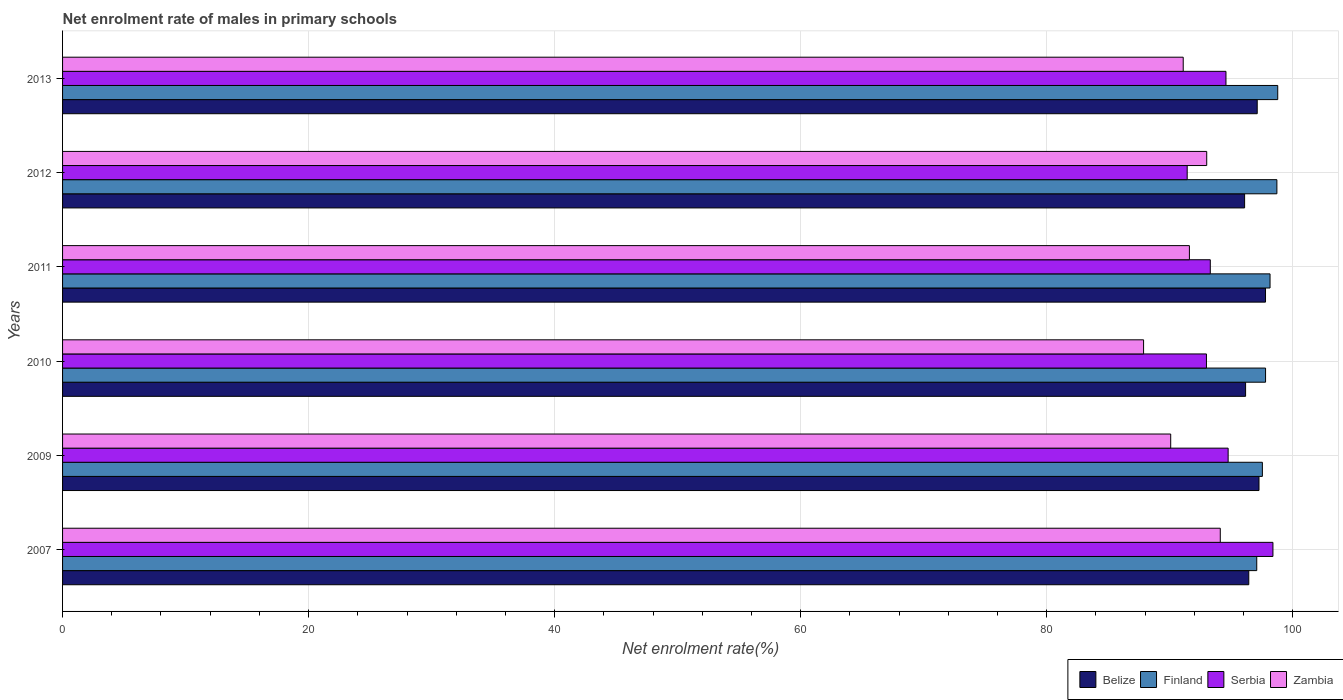How many groups of bars are there?
Your response must be concise. 6. What is the label of the 5th group of bars from the top?
Provide a short and direct response. 2009. What is the net enrolment rate of males in primary schools in Serbia in 2012?
Give a very brief answer. 91.43. Across all years, what is the maximum net enrolment rate of males in primary schools in Zambia?
Provide a succinct answer. 94.12. Across all years, what is the minimum net enrolment rate of males in primary schools in Zambia?
Your answer should be compact. 87.88. What is the total net enrolment rate of males in primary schools in Belize in the graph?
Give a very brief answer. 580.88. What is the difference between the net enrolment rate of males in primary schools in Serbia in 2007 and that in 2009?
Offer a terse response. 3.64. What is the difference between the net enrolment rate of males in primary schools in Belize in 2010 and the net enrolment rate of males in primary schools in Finland in 2011?
Your response must be concise. -1.99. What is the average net enrolment rate of males in primary schools in Belize per year?
Your response must be concise. 96.81. In the year 2011, what is the difference between the net enrolment rate of males in primary schools in Zambia and net enrolment rate of males in primary schools in Serbia?
Offer a terse response. -1.7. In how many years, is the net enrolment rate of males in primary schools in Serbia greater than 16 %?
Ensure brevity in your answer.  6. What is the ratio of the net enrolment rate of males in primary schools in Serbia in 2011 to that in 2013?
Ensure brevity in your answer.  0.99. Is the difference between the net enrolment rate of males in primary schools in Zambia in 2011 and 2012 greater than the difference between the net enrolment rate of males in primary schools in Serbia in 2011 and 2012?
Offer a very short reply. No. What is the difference between the highest and the second highest net enrolment rate of males in primary schools in Zambia?
Make the answer very short. 1.1. What is the difference between the highest and the lowest net enrolment rate of males in primary schools in Zambia?
Provide a succinct answer. 6.23. Is it the case that in every year, the sum of the net enrolment rate of males in primary schools in Finland and net enrolment rate of males in primary schools in Zambia is greater than the sum of net enrolment rate of males in primary schools in Belize and net enrolment rate of males in primary schools in Serbia?
Your answer should be very brief. Yes. What does the 1st bar from the top in 2013 represents?
Keep it short and to the point. Zambia. What does the 4th bar from the bottom in 2009 represents?
Provide a succinct answer. Zambia. Are all the bars in the graph horizontal?
Offer a terse response. Yes. How many years are there in the graph?
Your response must be concise. 6. What is the difference between two consecutive major ticks on the X-axis?
Provide a succinct answer. 20. Are the values on the major ticks of X-axis written in scientific E-notation?
Provide a succinct answer. No. Does the graph contain any zero values?
Your response must be concise. No. Does the graph contain grids?
Provide a short and direct response. Yes. How many legend labels are there?
Provide a short and direct response. 4. What is the title of the graph?
Your response must be concise. Net enrolment rate of males in primary schools. Does "United Kingdom" appear as one of the legend labels in the graph?
Your response must be concise. No. What is the label or title of the X-axis?
Provide a short and direct response. Net enrolment rate(%). What is the Net enrolment rate(%) in Belize in 2007?
Ensure brevity in your answer.  96.43. What is the Net enrolment rate(%) of Finland in 2007?
Your response must be concise. 97.08. What is the Net enrolment rate(%) in Serbia in 2007?
Provide a succinct answer. 98.4. What is the Net enrolment rate(%) of Zambia in 2007?
Offer a terse response. 94.12. What is the Net enrolment rate(%) of Belize in 2009?
Your response must be concise. 97.26. What is the Net enrolment rate(%) in Finland in 2009?
Offer a very short reply. 97.54. What is the Net enrolment rate(%) in Serbia in 2009?
Offer a terse response. 94.75. What is the Net enrolment rate(%) of Zambia in 2009?
Make the answer very short. 90.09. What is the Net enrolment rate(%) in Belize in 2010?
Your answer should be very brief. 96.17. What is the Net enrolment rate(%) in Finland in 2010?
Your response must be concise. 97.8. What is the Net enrolment rate(%) of Serbia in 2010?
Make the answer very short. 92.99. What is the Net enrolment rate(%) in Zambia in 2010?
Ensure brevity in your answer.  87.88. What is the Net enrolment rate(%) in Belize in 2011?
Your answer should be very brief. 97.79. What is the Net enrolment rate(%) of Finland in 2011?
Make the answer very short. 98.16. What is the Net enrolment rate(%) in Serbia in 2011?
Give a very brief answer. 93.3. What is the Net enrolment rate(%) in Zambia in 2011?
Keep it short and to the point. 91.61. What is the Net enrolment rate(%) in Belize in 2012?
Give a very brief answer. 96.09. What is the Net enrolment rate(%) of Finland in 2012?
Provide a succinct answer. 98.72. What is the Net enrolment rate(%) of Serbia in 2012?
Your answer should be compact. 91.43. What is the Net enrolment rate(%) in Zambia in 2012?
Ensure brevity in your answer.  93.01. What is the Net enrolment rate(%) in Belize in 2013?
Your answer should be compact. 97.12. What is the Net enrolment rate(%) in Finland in 2013?
Offer a very short reply. 98.79. What is the Net enrolment rate(%) of Serbia in 2013?
Your response must be concise. 94.58. What is the Net enrolment rate(%) of Zambia in 2013?
Provide a succinct answer. 91.1. Across all years, what is the maximum Net enrolment rate(%) of Belize?
Provide a succinct answer. 97.79. Across all years, what is the maximum Net enrolment rate(%) of Finland?
Your response must be concise. 98.79. Across all years, what is the maximum Net enrolment rate(%) of Serbia?
Offer a terse response. 98.4. Across all years, what is the maximum Net enrolment rate(%) of Zambia?
Your answer should be compact. 94.12. Across all years, what is the minimum Net enrolment rate(%) of Belize?
Your answer should be very brief. 96.09. Across all years, what is the minimum Net enrolment rate(%) of Finland?
Offer a very short reply. 97.08. Across all years, what is the minimum Net enrolment rate(%) in Serbia?
Your answer should be very brief. 91.43. Across all years, what is the minimum Net enrolment rate(%) of Zambia?
Your answer should be compact. 87.88. What is the total Net enrolment rate(%) of Belize in the graph?
Your answer should be compact. 580.88. What is the total Net enrolment rate(%) in Finland in the graph?
Provide a succinct answer. 588.08. What is the total Net enrolment rate(%) in Serbia in the graph?
Make the answer very short. 565.45. What is the total Net enrolment rate(%) in Zambia in the graph?
Offer a very short reply. 547.8. What is the difference between the Net enrolment rate(%) in Belize in 2007 and that in 2009?
Make the answer very short. -0.83. What is the difference between the Net enrolment rate(%) in Finland in 2007 and that in 2009?
Your response must be concise. -0.46. What is the difference between the Net enrolment rate(%) of Serbia in 2007 and that in 2009?
Your response must be concise. 3.64. What is the difference between the Net enrolment rate(%) in Zambia in 2007 and that in 2009?
Keep it short and to the point. 4.03. What is the difference between the Net enrolment rate(%) in Belize in 2007 and that in 2010?
Keep it short and to the point. 0.26. What is the difference between the Net enrolment rate(%) of Finland in 2007 and that in 2010?
Keep it short and to the point. -0.72. What is the difference between the Net enrolment rate(%) of Serbia in 2007 and that in 2010?
Give a very brief answer. 5.41. What is the difference between the Net enrolment rate(%) of Zambia in 2007 and that in 2010?
Your answer should be very brief. 6.23. What is the difference between the Net enrolment rate(%) of Belize in 2007 and that in 2011?
Provide a succinct answer. -1.36. What is the difference between the Net enrolment rate(%) in Finland in 2007 and that in 2011?
Offer a very short reply. -1.08. What is the difference between the Net enrolment rate(%) of Serbia in 2007 and that in 2011?
Ensure brevity in your answer.  5.09. What is the difference between the Net enrolment rate(%) of Zambia in 2007 and that in 2011?
Your answer should be very brief. 2.51. What is the difference between the Net enrolment rate(%) in Belize in 2007 and that in 2012?
Your answer should be compact. 0.34. What is the difference between the Net enrolment rate(%) in Finland in 2007 and that in 2012?
Keep it short and to the point. -1.64. What is the difference between the Net enrolment rate(%) of Serbia in 2007 and that in 2012?
Make the answer very short. 6.97. What is the difference between the Net enrolment rate(%) in Zambia in 2007 and that in 2012?
Make the answer very short. 1.1. What is the difference between the Net enrolment rate(%) in Belize in 2007 and that in 2013?
Offer a very short reply. -0.69. What is the difference between the Net enrolment rate(%) of Finland in 2007 and that in 2013?
Your answer should be very brief. -1.71. What is the difference between the Net enrolment rate(%) in Serbia in 2007 and that in 2013?
Your answer should be compact. 3.82. What is the difference between the Net enrolment rate(%) in Zambia in 2007 and that in 2013?
Give a very brief answer. 3.01. What is the difference between the Net enrolment rate(%) of Belize in 2009 and that in 2010?
Provide a succinct answer. 1.09. What is the difference between the Net enrolment rate(%) in Finland in 2009 and that in 2010?
Provide a succinct answer. -0.26. What is the difference between the Net enrolment rate(%) in Serbia in 2009 and that in 2010?
Provide a short and direct response. 1.76. What is the difference between the Net enrolment rate(%) in Zambia in 2009 and that in 2010?
Your answer should be very brief. 2.2. What is the difference between the Net enrolment rate(%) of Belize in 2009 and that in 2011?
Ensure brevity in your answer.  -0.53. What is the difference between the Net enrolment rate(%) of Finland in 2009 and that in 2011?
Your answer should be very brief. -0.62. What is the difference between the Net enrolment rate(%) in Serbia in 2009 and that in 2011?
Your answer should be very brief. 1.45. What is the difference between the Net enrolment rate(%) in Zambia in 2009 and that in 2011?
Your response must be concise. -1.52. What is the difference between the Net enrolment rate(%) of Belize in 2009 and that in 2012?
Your answer should be very brief. 1.17. What is the difference between the Net enrolment rate(%) of Finland in 2009 and that in 2012?
Offer a terse response. -1.18. What is the difference between the Net enrolment rate(%) of Serbia in 2009 and that in 2012?
Your answer should be very brief. 3.33. What is the difference between the Net enrolment rate(%) of Zambia in 2009 and that in 2012?
Give a very brief answer. -2.93. What is the difference between the Net enrolment rate(%) of Belize in 2009 and that in 2013?
Offer a terse response. 0.15. What is the difference between the Net enrolment rate(%) of Finland in 2009 and that in 2013?
Provide a succinct answer. -1.25. What is the difference between the Net enrolment rate(%) in Serbia in 2009 and that in 2013?
Ensure brevity in your answer.  0.18. What is the difference between the Net enrolment rate(%) in Zambia in 2009 and that in 2013?
Your answer should be very brief. -1.02. What is the difference between the Net enrolment rate(%) of Belize in 2010 and that in 2011?
Provide a succinct answer. -1.62. What is the difference between the Net enrolment rate(%) in Finland in 2010 and that in 2011?
Give a very brief answer. -0.36. What is the difference between the Net enrolment rate(%) in Serbia in 2010 and that in 2011?
Offer a terse response. -0.31. What is the difference between the Net enrolment rate(%) of Zambia in 2010 and that in 2011?
Your answer should be very brief. -3.73. What is the difference between the Net enrolment rate(%) in Belize in 2010 and that in 2012?
Offer a terse response. 0.08. What is the difference between the Net enrolment rate(%) in Finland in 2010 and that in 2012?
Give a very brief answer. -0.92. What is the difference between the Net enrolment rate(%) of Serbia in 2010 and that in 2012?
Your answer should be compact. 1.57. What is the difference between the Net enrolment rate(%) in Zambia in 2010 and that in 2012?
Your answer should be very brief. -5.13. What is the difference between the Net enrolment rate(%) in Belize in 2010 and that in 2013?
Keep it short and to the point. -0.94. What is the difference between the Net enrolment rate(%) in Finland in 2010 and that in 2013?
Offer a terse response. -0.99. What is the difference between the Net enrolment rate(%) in Serbia in 2010 and that in 2013?
Offer a very short reply. -1.59. What is the difference between the Net enrolment rate(%) of Zambia in 2010 and that in 2013?
Offer a terse response. -3.22. What is the difference between the Net enrolment rate(%) in Belize in 2011 and that in 2012?
Your answer should be compact. 1.7. What is the difference between the Net enrolment rate(%) in Finland in 2011 and that in 2012?
Give a very brief answer. -0.56. What is the difference between the Net enrolment rate(%) of Serbia in 2011 and that in 2012?
Your answer should be very brief. 1.88. What is the difference between the Net enrolment rate(%) of Zambia in 2011 and that in 2012?
Your response must be concise. -1.41. What is the difference between the Net enrolment rate(%) of Belize in 2011 and that in 2013?
Provide a succinct answer. 0.67. What is the difference between the Net enrolment rate(%) of Finland in 2011 and that in 2013?
Your answer should be very brief. -0.62. What is the difference between the Net enrolment rate(%) in Serbia in 2011 and that in 2013?
Keep it short and to the point. -1.27. What is the difference between the Net enrolment rate(%) of Zambia in 2011 and that in 2013?
Give a very brief answer. 0.5. What is the difference between the Net enrolment rate(%) of Belize in 2012 and that in 2013?
Make the answer very short. -1.03. What is the difference between the Net enrolment rate(%) in Finland in 2012 and that in 2013?
Provide a succinct answer. -0.07. What is the difference between the Net enrolment rate(%) in Serbia in 2012 and that in 2013?
Offer a terse response. -3.15. What is the difference between the Net enrolment rate(%) of Zambia in 2012 and that in 2013?
Your response must be concise. 1.91. What is the difference between the Net enrolment rate(%) in Belize in 2007 and the Net enrolment rate(%) in Finland in 2009?
Your answer should be compact. -1.11. What is the difference between the Net enrolment rate(%) in Belize in 2007 and the Net enrolment rate(%) in Serbia in 2009?
Keep it short and to the point. 1.68. What is the difference between the Net enrolment rate(%) in Belize in 2007 and the Net enrolment rate(%) in Zambia in 2009?
Provide a short and direct response. 6.35. What is the difference between the Net enrolment rate(%) of Finland in 2007 and the Net enrolment rate(%) of Serbia in 2009?
Your response must be concise. 2.33. What is the difference between the Net enrolment rate(%) in Finland in 2007 and the Net enrolment rate(%) in Zambia in 2009?
Your response must be concise. 7. What is the difference between the Net enrolment rate(%) in Serbia in 2007 and the Net enrolment rate(%) in Zambia in 2009?
Provide a succinct answer. 8.31. What is the difference between the Net enrolment rate(%) in Belize in 2007 and the Net enrolment rate(%) in Finland in 2010?
Give a very brief answer. -1.36. What is the difference between the Net enrolment rate(%) in Belize in 2007 and the Net enrolment rate(%) in Serbia in 2010?
Keep it short and to the point. 3.44. What is the difference between the Net enrolment rate(%) in Belize in 2007 and the Net enrolment rate(%) in Zambia in 2010?
Make the answer very short. 8.55. What is the difference between the Net enrolment rate(%) of Finland in 2007 and the Net enrolment rate(%) of Serbia in 2010?
Provide a succinct answer. 4.09. What is the difference between the Net enrolment rate(%) of Finland in 2007 and the Net enrolment rate(%) of Zambia in 2010?
Your response must be concise. 9.2. What is the difference between the Net enrolment rate(%) of Serbia in 2007 and the Net enrolment rate(%) of Zambia in 2010?
Your answer should be compact. 10.52. What is the difference between the Net enrolment rate(%) of Belize in 2007 and the Net enrolment rate(%) of Finland in 2011?
Your answer should be very brief. -1.73. What is the difference between the Net enrolment rate(%) in Belize in 2007 and the Net enrolment rate(%) in Serbia in 2011?
Give a very brief answer. 3.13. What is the difference between the Net enrolment rate(%) of Belize in 2007 and the Net enrolment rate(%) of Zambia in 2011?
Provide a short and direct response. 4.83. What is the difference between the Net enrolment rate(%) in Finland in 2007 and the Net enrolment rate(%) in Serbia in 2011?
Provide a succinct answer. 3.78. What is the difference between the Net enrolment rate(%) in Finland in 2007 and the Net enrolment rate(%) in Zambia in 2011?
Offer a very short reply. 5.47. What is the difference between the Net enrolment rate(%) of Serbia in 2007 and the Net enrolment rate(%) of Zambia in 2011?
Make the answer very short. 6.79. What is the difference between the Net enrolment rate(%) of Belize in 2007 and the Net enrolment rate(%) of Finland in 2012?
Provide a succinct answer. -2.29. What is the difference between the Net enrolment rate(%) of Belize in 2007 and the Net enrolment rate(%) of Serbia in 2012?
Make the answer very short. 5.01. What is the difference between the Net enrolment rate(%) of Belize in 2007 and the Net enrolment rate(%) of Zambia in 2012?
Provide a short and direct response. 3.42. What is the difference between the Net enrolment rate(%) in Finland in 2007 and the Net enrolment rate(%) in Serbia in 2012?
Your response must be concise. 5.66. What is the difference between the Net enrolment rate(%) in Finland in 2007 and the Net enrolment rate(%) in Zambia in 2012?
Your answer should be very brief. 4.07. What is the difference between the Net enrolment rate(%) in Serbia in 2007 and the Net enrolment rate(%) in Zambia in 2012?
Give a very brief answer. 5.38. What is the difference between the Net enrolment rate(%) in Belize in 2007 and the Net enrolment rate(%) in Finland in 2013?
Your answer should be very brief. -2.35. What is the difference between the Net enrolment rate(%) of Belize in 2007 and the Net enrolment rate(%) of Serbia in 2013?
Make the answer very short. 1.85. What is the difference between the Net enrolment rate(%) of Belize in 2007 and the Net enrolment rate(%) of Zambia in 2013?
Offer a very short reply. 5.33. What is the difference between the Net enrolment rate(%) in Finland in 2007 and the Net enrolment rate(%) in Serbia in 2013?
Provide a short and direct response. 2.5. What is the difference between the Net enrolment rate(%) of Finland in 2007 and the Net enrolment rate(%) of Zambia in 2013?
Your answer should be very brief. 5.98. What is the difference between the Net enrolment rate(%) in Serbia in 2007 and the Net enrolment rate(%) in Zambia in 2013?
Your answer should be compact. 7.29. What is the difference between the Net enrolment rate(%) in Belize in 2009 and the Net enrolment rate(%) in Finland in 2010?
Provide a short and direct response. -0.53. What is the difference between the Net enrolment rate(%) of Belize in 2009 and the Net enrolment rate(%) of Serbia in 2010?
Keep it short and to the point. 4.27. What is the difference between the Net enrolment rate(%) in Belize in 2009 and the Net enrolment rate(%) in Zambia in 2010?
Your answer should be very brief. 9.38. What is the difference between the Net enrolment rate(%) of Finland in 2009 and the Net enrolment rate(%) of Serbia in 2010?
Make the answer very short. 4.55. What is the difference between the Net enrolment rate(%) of Finland in 2009 and the Net enrolment rate(%) of Zambia in 2010?
Offer a terse response. 9.66. What is the difference between the Net enrolment rate(%) of Serbia in 2009 and the Net enrolment rate(%) of Zambia in 2010?
Offer a very short reply. 6.87. What is the difference between the Net enrolment rate(%) in Belize in 2009 and the Net enrolment rate(%) in Finland in 2011?
Your answer should be very brief. -0.9. What is the difference between the Net enrolment rate(%) in Belize in 2009 and the Net enrolment rate(%) in Serbia in 2011?
Offer a very short reply. 3.96. What is the difference between the Net enrolment rate(%) in Belize in 2009 and the Net enrolment rate(%) in Zambia in 2011?
Your answer should be compact. 5.66. What is the difference between the Net enrolment rate(%) in Finland in 2009 and the Net enrolment rate(%) in Serbia in 2011?
Provide a short and direct response. 4.23. What is the difference between the Net enrolment rate(%) of Finland in 2009 and the Net enrolment rate(%) of Zambia in 2011?
Your answer should be compact. 5.93. What is the difference between the Net enrolment rate(%) of Serbia in 2009 and the Net enrolment rate(%) of Zambia in 2011?
Provide a short and direct response. 3.15. What is the difference between the Net enrolment rate(%) of Belize in 2009 and the Net enrolment rate(%) of Finland in 2012?
Keep it short and to the point. -1.45. What is the difference between the Net enrolment rate(%) in Belize in 2009 and the Net enrolment rate(%) in Serbia in 2012?
Your answer should be compact. 5.84. What is the difference between the Net enrolment rate(%) of Belize in 2009 and the Net enrolment rate(%) of Zambia in 2012?
Provide a succinct answer. 4.25. What is the difference between the Net enrolment rate(%) of Finland in 2009 and the Net enrolment rate(%) of Serbia in 2012?
Make the answer very short. 6.11. What is the difference between the Net enrolment rate(%) in Finland in 2009 and the Net enrolment rate(%) in Zambia in 2012?
Your answer should be compact. 4.53. What is the difference between the Net enrolment rate(%) of Serbia in 2009 and the Net enrolment rate(%) of Zambia in 2012?
Keep it short and to the point. 1.74. What is the difference between the Net enrolment rate(%) of Belize in 2009 and the Net enrolment rate(%) of Finland in 2013?
Your response must be concise. -1.52. What is the difference between the Net enrolment rate(%) in Belize in 2009 and the Net enrolment rate(%) in Serbia in 2013?
Your response must be concise. 2.69. What is the difference between the Net enrolment rate(%) of Belize in 2009 and the Net enrolment rate(%) of Zambia in 2013?
Your response must be concise. 6.16. What is the difference between the Net enrolment rate(%) of Finland in 2009 and the Net enrolment rate(%) of Serbia in 2013?
Ensure brevity in your answer.  2.96. What is the difference between the Net enrolment rate(%) of Finland in 2009 and the Net enrolment rate(%) of Zambia in 2013?
Offer a very short reply. 6.44. What is the difference between the Net enrolment rate(%) of Serbia in 2009 and the Net enrolment rate(%) of Zambia in 2013?
Provide a short and direct response. 3.65. What is the difference between the Net enrolment rate(%) in Belize in 2010 and the Net enrolment rate(%) in Finland in 2011?
Your response must be concise. -1.99. What is the difference between the Net enrolment rate(%) of Belize in 2010 and the Net enrolment rate(%) of Serbia in 2011?
Your answer should be very brief. 2.87. What is the difference between the Net enrolment rate(%) of Belize in 2010 and the Net enrolment rate(%) of Zambia in 2011?
Your response must be concise. 4.57. What is the difference between the Net enrolment rate(%) of Finland in 2010 and the Net enrolment rate(%) of Serbia in 2011?
Your response must be concise. 4.49. What is the difference between the Net enrolment rate(%) in Finland in 2010 and the Net enrolment rate(%) in Zambia in 2011?
Offer a terse response. 6.19. What is the difference between the Net enrolment rate(%) in Serbia in 2010 and the Net enrolment rate(%) in Zambia in 2011?
Your answer should be compact. 1.39. What is the difference between the Net enrolment rate(%) in Belize in 2010 and the Net enrolment rate(%) in Finland in 2012?
Provide a succinct answer. -2.54. What is the difference between the Net enrolment rate(%) in Belize in 2010 and the Net enrolment rate(%) in Serbia in 2012?
Keep it short and to the point. 4.75. What is the difference between the Net enrolment rate(%) in Belize in 2010 and the Net enrolment rate(%) in Zambia in 2012?
Your answer should be compact. 3.16. What is the difference between the Net enrolment rate(%) of Finland in 2010 and the Net enrolment rate(%) of Serbia in 2012?
Offer a terse response. 6.37. What is the difference between the Net enrolment rate(%) of Finland in 2010 and the Net enrolment rate(%) of Zambia in 2012?
Provide a succinct answer. 4.78. What is the difference between the Net enrolment rate(%) in Serbia in 2010 and the Net enrolment rate(%) in Zambia in 2012?
Give a very brief answer. -0.02. What is the difference between the Net enrolment rate(%) in Belize in 2010 and the Net enrolment rate(%) in Finland in 2013?
Offer a very short reply. -2.61. What is the difference between the Net enrolment rate(%) of Belize in 2010 and the Net enrolment rate(%) of Serbia in 2013?
Provide a succinct answer. 1.6. What is the difference between the Net enrolment rate(%) in Belize in 2010 and the Net enrolment rate(%) in Zambia in 2013?
Your answer should be compact. 5.07. What is the difference between the Net enrolment rate(%) of Finland in 2010 and the Net enrolment rate(%) of Serbia in 2013?
Provide a short and direct response. 3.22. What is the difference between the Net enrolment rate(%) in Finland in 2010 and the Net enrolment rate(%) in Zambia in 2013?
Offer a terse response. 6.69. What is the difference between the Net enrolment rate(%) of Serbia in 2010 and the Net enrolment rate(%) of Zambia in 2013?
Give a very brief answer. 1.89. What is the difference between the Net enrolment rate(%) in Belize in 2011 and the Net enrolment rate(%) in Finland in 2012?
Provide a short and direct response. -0.92. What is the difference between the Net enrolment rate(%) in Belize in 2011 and the Net enrolment rate(%) in Serbia in 2012?
Your response must be concise. 6.37. What is the difference between the Net enrolment rate(%) of Belize in 2011 and the Net enrolment rate(%) of Zambia in 2012?
Your answer should be compact. 4.78. What is the difference between the Net enrolment rate(%) of Finland in 2011 and the Net enrolment rate(%) of Serbia in 2012?
Provide a short and direct response. 6.74. What is the difference between the Net enrolment rate(%) in Finland in 2011 and the Net enrolment rate(%) in Zambia in 2012?
Provide a short and direct response. 5.15. What is the difference between the Net enrolment rate(%) in Serbia in 2011 and the Net enrolment rate(%) in Zambia in 2012?
Ensure brevity in your answer.  0.29. What is the difference between the Net enrolment rate(%) in Belize in 2011 and the Net enrolment rate(%) in Finland in 2013?
Ensure brevity in your answer.  -0.99. What is the difference between the Net enrolment rate(%) of Belize in 2011 and the Net enrolment rate(%) of Serbia in 2013?
Offer a very short reply. 3.21. What is the difference between the Net enrolment rate(%) in Belize in 2011 and the Net enrolment rate(%) in Zambia in 2013?
Keep it short and to the point. 6.69. What is the difference between the Net enrolment rate(%) in Finland in 2011 and the Net enrolment rate(%) in Serbia in 2013?
Provide a succinct answer. 3.58. What is the difference between the Net enrolment rate(%) of Finland in 2011 and the Net enrolment rate(%) of Zambia in 2013?
Give a very brief answer. 7.06. What is the difference between the Net enrolment rate(%) in Serbia in 2011 and the Net enrolment rate(%) in Zambia in 2013?
Ensure brevity in your answer.  2.2. What is the difference between the Net enrolment rate(%) in Belize in 2012 and the Net enrolment rate(%) in Finland in 2013?
Offer a very short reply. -2.69. What is the difference between the Net enrolment rate(%) of Belize in 2012 and the Net enrolment rate(%) of Serbia in 2013?
Keep it short and to the point. 1.51. What is the difference between the Net enrolment rate(%) of Belize in 2012 and the Net enrolment rate(%) of Zambia in 2013?
Ensure brevity in your answer.  4.99. What is the difference between the Net enrolment rate(%) in Finland in 2012 and the Net enrolment rate(%) in Serbia in 2013?
Give a very brief answer. 4.14. What is the difference between the Net enrolment rate(%) of Finland in 2012 and the Net enrolment rate(%) of Zambia in 2013?
Your answer should be very brief. 7.62. What is the difference between the Net enrolment rate(%) in Serbia in 2012 and the Net enrolment rate(%) in Zambia in 2013?
Offer a terse response. 0.32. What is the average Net enrolment rate(%) in Belize per year?
Provide a short and direct response. 96.81. What is the average Net enrolment rate(%) in Finland per year?
Offer a very short reply. 98.01. What is the average Net enrolment rate(%) in Serbia per year?
Make the answer very short. 94.24. What is the average Net enrolment rate(%) in Zambia per year?
Give a very brief answer. 91.3. In the year 2007, what is the difference between the Net enrolment rate(%) of Belize and Net enrolment rate(%) of Finland?
Offer a very short reply. -0.65. In the year 2007, what is the difference between the Net enrolment rate(%) in Belize and Net enrolment rate(%) in Serbia?
Offer a terse response. -1.96. In the year 2007, what is the difference between the Net enrolment rate(%) in Belize and Net enrolment rate(%) in Zambia?
Give a very brief answer. 2.32. In the year 2007, what is the difference between the Net enrolment rate(%) in Finland and Net enrolment rate(%) in Serbia?
Keep it short and to the point. -1.32. In the year 2007, what is the difference between the Net enrolment rate(%) of Finland and Net enrolment rate(%) of Zambia?
Ensure brevity in your answer.  2.97. In the year 2007, what is the difference between the Net enrolment rate(%) of Serbia and Net enrolment rate(%) of Zambia?
Offer a very short reply. 4.28. In the year 2009, what is the difference between the Net enrolment rate(%) in Belize and Net enrolment rate(%) in Finland?
Give a very brief answer. -0.27. In the year 2009, what is the difference between the Net enrolment rate(%) in Belize and Net enrolment rate(%) in Serbia?
Provide a succinct answer. 2.51. In the year 2009, what is the difference between the Net enrolment rate(%) in Belize and Net enrolment rate(%) in Zambia?
Your response must be concise. 7.18. In the year 2009, what is the difference between the Net enrolment rate(%) in Finland and Net enrolment rate(%) in Serbia?
Your answer should be very brief. 2.78. In the year 2009, what is the difference between the Net enrolment rate(%) of Finland and Net enrolment rate(%) of Zambia?
Keep it short and to the point. 7.45. In the year 2009, what is the difference between the Net enrolment rate(%) in Serbia and Net enrolment rate(%) in Zambia?
Provide a short and direct response. 4.67. In the year 2010, what is the difference between the Net enrolment rate(%) of Belize and Net enrolment rate(%) of Finland?
Your answer should be very brief. -1.62. In the year 2010, what is the difference between the Net enrolment rate(%) of Belize and Net enrolment rate(%) of Serbia?
Your answer should be very brief. 3.18. In the year 2010, what is the difference between the Net enrolment rate(%) of Belize and Net enrolment rate(%) of Zambia?
Your answer should be very brief. 8.29. In the year 2010, what is the difference between the Net enrolment rate(%) of Finland and Net enrolment rate(%) of Serbia?
Ensure brevity in your answer.  4.81. In the year 2010, what is the difference between the Net enrolment rate(%) in Finland and Net enrolment rate(%) in Zambia?
Provide a short and direct response. 9.92. In the year 2010, what is the difference between the Net enrolment rate(%) in Serbia and Net enrolment rate(%) in Zambia?
Offer a very short reply. 5.11. In the year 2011, what is the difference between the Net enrolment rate(%) in Belize and Net enrolment rate(%) in Finland?
Offer a terse response. -0.37. In the year 2011, what is the difference between the Net enrolment rate(%) of Belize and Net enrolment rate(%) of Serbia?
Your response must be concise. 4.49. In the year 2011, what is the difference between the Net enrolment rate(%) of Belize and Net enrolment rate(%) of Zambia?
Make the answer very short. 6.19. In the year 2011, what is the difference between the Net enrolment rate(%) of Finland and Net enrolment rate(%) of Serbia?
Offer a very short reply. 4.86. In the year 2011, what is the difference between the Net enrolment rate(%) of Finland and Net enrolment rate(%) of Zambia?
Your response must be concise. 6.56. In the year 2011, what is the difference between the Net enrolment rate(%) of Serbia and Net enrolment rate(%) of Zambia?
Keep it short and to the point. 1.7. In the year 2012, what is the difference between the Net enrolment rate(%) in Belize and Net enrolment rate(%) in Finland?
Your answer should be compact. -2.62. In the year 2012, what is the difference between the Net enrolment rate(%) in Belize and Net enrolment rate(%) in Serbia?
Your response must be concise. 4.67. In the year 2012, what is the difference between the Net enrolment rate(%) of Belize and Net enrolment rate(%) of Zambia?
Keep it short and to the point. 3.08. In the year 2012, what is the difference between the Net enrolment rate(%) of Finland and Net enrolment rate(%) of Serbia?
Make the answer very short. 7.29. In the year 2012, what is the difference between the Net enrolment rate(%) of Finland and Net enrolment rate(%) of Zambia?
Offer a very short reply. 5.7. In the year 2012, what is the difference between the Net enrolment rate(%) of Serbia and Net enrolment rate(%) of Zambia?
Ensure brevity in your answer.  -1.59. In the year 2013, what is the difference between the Net enrolment rate(%) of Belize and Net enrolment rate(%) of Finland?
Your response must be concise. -1.67. In the year 2013, what is the difference between the Net enrolment rate(%) of Belize and Net enrolment rate(%) of Serbia?
Ensure brevity in your answer.  2.54. In the year 2013, what is the difference between the Net enrolment rate(%) in Belize and Net enrolment rate(%) in Zambia?
Your response must be concise. 6.02. In the year 2013, what is the difference between the Net enrolment rate(%) of Finland and Net enrolment rate(%) of Serbia?
Make the answer very short. 4.21. In the year 2013, what is the difference between the Net enrolment rate(%) of Finland and Net enrolment rate(%) of Zambia?
Provide a short and direct response. 7.68. In the year 2013, what is the difference between the Net enrolment rate(%) in Serbia and Net enrolment rate(%) in Zambia?
Provide a short and direct response. 3.48. What is the ratio of the Net enrolment rate(%) in Serbia in 2007 to that in 2009?
Give a very brief answer. 1.04. What is the ratio of the Net enrolment rate(%) in Zambia in 2007 to that in 2009?
Offer a terse response. 1.04. What is the ratio of the Net enrolment rate(%) of Belize in 2007 to that in 2010?
Your answer should be compact. 1. What is the ratio of the Net enrolment rate(%) of Finland in 2007 to that in 2010?
Give a very brief answer. 0.99. What is the ratio of the Net enrolment rate(%) in Serbia in 2007 to that in 2010?
Ensure brevity in your answer.  1.06. What is the ratio of the Net enrolment rate(%) of Zambia in 2007 to that in 2010?
Give a very brief answer. 1.07. What is the ratio of the Net enrolment rate(%) in Belize in 2007 to that in 2011?
Your response must be concise. 0.99. What is the ratio of the Net enrolment rate(%) of Finland in 2007 to that in 2011?
Ensure brevity in your answer.  0.99. What is the ratio of the Net enrolment rate(%) of Serbia in 2007 to that in 2011?
Give a very brief answer. 1.05. What is the ratio of the Net enrolment rate(%) in Zambia in 2007 to that in 2011?
Provide a short and direct response. 1.03. What is the ratio of the Net enrolment rate(%) of Finland in 2007 to that in 2012?
Offer a terse response. 0.98. What is the ratio of the Net enrolment rate(%) of Serbia in 2007 to that in 2012?
Provide a short and direct response. 1.08. What is the ratio of the Net enrolment rate(%) in Zambia in 2007 to that in 2012?
Provide a succinct answer. 1.01. What is the ratio of the Net enrolment rate(%) of Belize in 2007 to that in 2013?
Offer a very short reply. 0.99. What is the ratio of the Net enrolment rate(%) of Finland in 2007 to that in 2013?
Your answer should be compact. 0.98. What is the ratio of the Net enrolment rate(%) in Serbia in 2007 to that in 2013?
Provide a short and direct response. 1.04. What is the ratio of the Net enrolment rate(%) of Zambia in 2007 to that in 2013?
Keep it short and to the point. 1.03. What is the ratio of the Net enrolment rate(%) in Belize in 2009 to that in 2010?
Provide a succinct answer. 1.01. What is the ratio of the Net enrolment rate(%) in Finland in 2009 to that in 2010?
Your answer should be compact. 1. What is the ratio of the Net enrolment rate(%) in Serbia in 2009 to that in 2010?
Offer a terse response. 1.02. What is the ratio of the Net enrolment rate(%) of Zambia in 2009 to that in 2010?
Ensure brevity in your answer.  1.03. What is the ratio of the Net enrolment rate(%) in Belize in 2009 to that in 2011?
Make the answer very short. 0.99. What is the ratio of the Net enrolment rate(%) in Serbia in 2009 to that in 2011?
Ensure brevity in your answer.  1.02. What is the ratio of the Net enrolment rate(%) in Zambia in 2009 to that in 2011?
Offer a terse response. 0.98. What is the ratio of the Net enrolment rate(%) of Belize in 2009 to that in 2012?
Your answer should be very brief. 1.01. What is the ratio of the Net enrolment rate(%) in Finland in 2009 to that in 2012?
Provide a short and direct response. 0.99. What is the ratio of the Net enrolment rate(%) of Serbia in 2009 to that in 2012?
Keep it short and to the point. 1.04. What is the ratio of the Net enrolment rate(%) in Zambia in 2009 to that in 2012?
Give a very brief answer. 0.97. What is the ratio of the Net enrolment rate(%) in Belize in 2009 to that in 2013?
Provide a succinct answer. 1. What is the ratio of the Net enrolment rate(%) in Finland in 2009 to that in 2013?
Provide a short and direct response. 0.99. What is the ratio of the Net enrolment rate(%) of Serbia in 2009 to that in 2013?
Provide a succinct answer. 1. What is the ratio of the Net enrolment rate(%) in Zambia in 2009 to that in 2013?
Provide a short and direct response. 0.99. What is the ratio of the Net enrolment rate(%) in Belize in 2010 to that in 2011?
Provide a succinct answer. 0.98. What is the ratio of the Net enrolment rate(%) in Zambia in 2010 to that in 2011?
Offer a very short reply. 0.96. What is the ratio of the Net enrolment rate(%) in Finland in 2010 to that in 2012?
Offer a terse response. 0.99. What is the ratio of the Net enrolment rate(%) of Serbia in 2010 to that in 2012?
Provide a short and direct response. 1.02. What is the ratio of the Net enrolment rate(%) in Zambia in 2010 to that in 2012?
Provide a succinct answer. 0.94. What is the ratio of the Net enrolment rate(%) in Belize in 2010 to that in 2013?
Make the answer very short. 0.99. What is the ratio of the Net enrolment rate(%) of Serbia in 2010 to that in 2013?
Keep it short and to the point. 0.98. What is the ratio of the Net enrolment rate(%) in Zambia in 2010 to that in 2013?
Offer a very short reply. 0.96. What is the ratio of the Net enrolment rate(%) of Belize in 2011 to that in 2012?
Give a very brief answer. 1.02. What is the ratio of the Net enrolment rate(%) in Serbia in 2011 to that in 2012?
Your answer should be very brief. 1.02. What is the ratio of the Net enrolment rate(%) of Zambia in 2011 to that in 2012?
Offer a very short reply. 0.98. What is the ratio of the Net enrolment rate(%) in Belize in 2011 to that in 2013?
Your answer should be very brief. 1.01. What is the ratio of the Net enrolment rate(%) of Finland in 2011 to that in 2013?
Give a very brief answer. 0.99. What is the ratio of the Net enrolment rate(%) of Serbia in 2011 to that in 2013?
Provide a short and direct response. 0.99. What is the ratio of the Net enrolment rate(%) of Serbia in 2012 to that in 2013?
Keep it short and to the point. 0.97. What is the ratio of the Net enrolment rate(%) of Zambia in 2012 to that in 2013?
Provide a succinct answer. 1.02. What is the difference between the highest and the second highest Net enrolment rate(%) of Belize?
Offer a very short reply. 0.53. What is the difference between the highest and the second highest Net enrolment rate(%) of Finland?
Give a very brief answer. 0.07. What is the difference between the highest and the second highest Net enrolment rate(%) in Serbia?
Your response must be concise. 3.64. What is the difference between the highest and the second highest Net enrolment rate(%) in Zambia?
Offer a very short reply. 1.1. What is the difference between the highest and the lowest Net enrolment rate(%) of Belize?
Provide a succinct answer. 1.7. What is the difference between the highest and the lowest Net enrolment rate(%) of Finland?
Your response must be concise. 1.71. What is the difference between the highest and the lowest Net enrolment rate(%) in Serbia?
Make the answer very short. 6.97. What is the difference between the highest and the lowest Net enrolment rate(%) of Zambia?
Give a very brief answer. 6.23. 